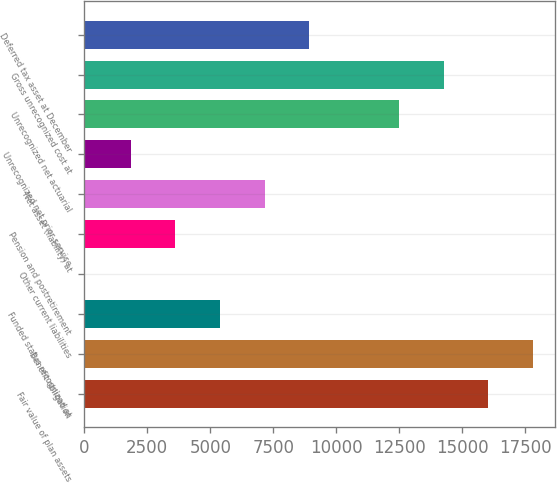<chart> <loc_0><loc_0><loc_500><loc_500><bar_chart><fcel>Fair value of plan assets<fcel>Benefit obligation<fcel>Funded status recognized at<fcel>Other current liabilities<fcel>Pension and postretirement<fcel>Net asset (liability) at<fcel>Unrecognized net prior service<fcel>Unrecognized net actuarial<fcel>Gross unrecognized cost at<fcel>Deferred tax asset at December<nl><fcel>16040.6<fcel>17815.8<fcel>5389.4<fcel>11<fcel>3614.2<fcel>7164.6<fcel>1839<fcel>12490.2<fcel>14265.4<fcel>8939.8<nl></chart> 